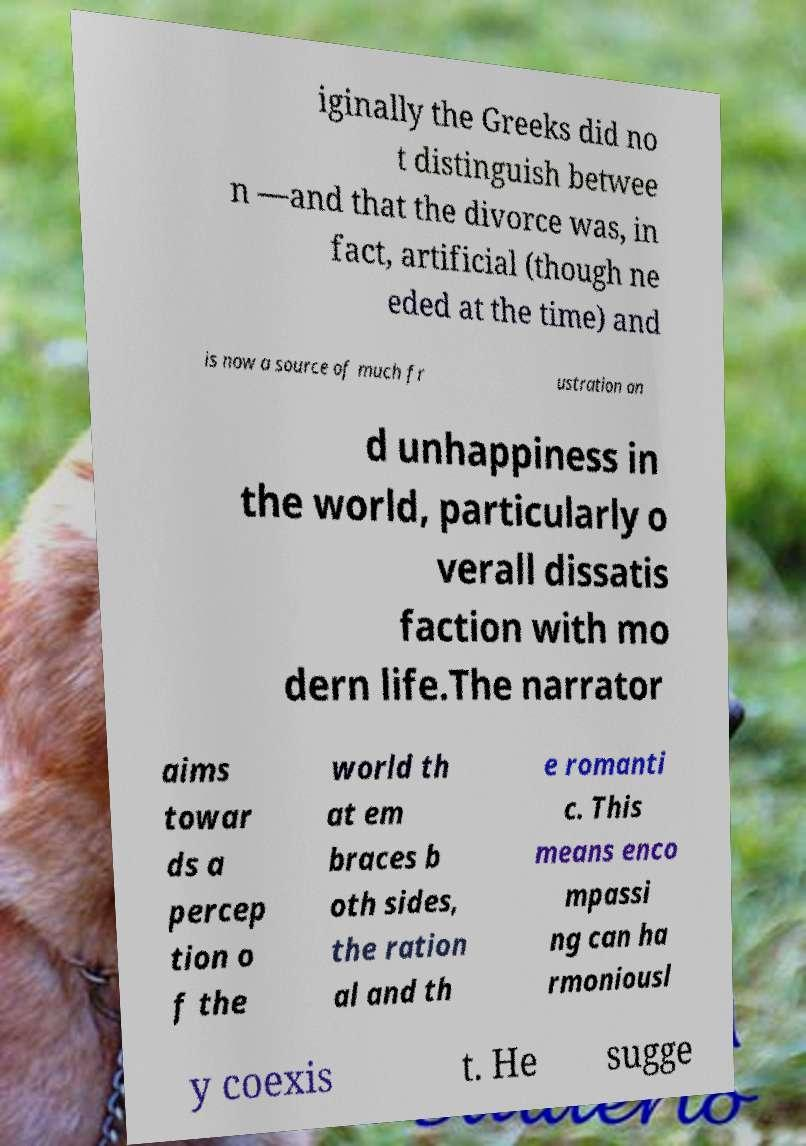Could you extract and type out the text from this image? iginally the Greeks did no t distinguish betwee n —and that the divorce was, in fact, artificial (though ne eded at the time) and is now a source of much fr ustration an d unhappiness in the world, particularly o verall dissatis faction with mo dern life.The narrator aims towar ds a percep tion o f the world th at em braces b oth sides, the ration al and th e romanti c. This means enco mpassi ng can ha rmoniousl y coexis t. He sugge 